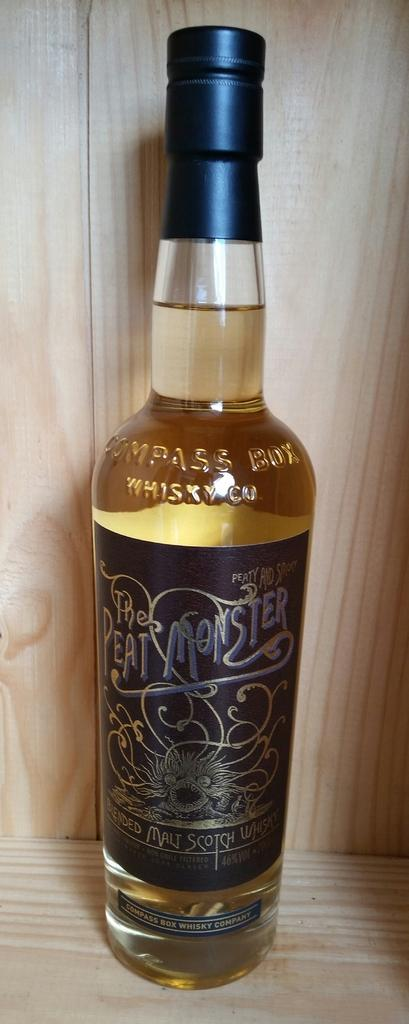<image>
Render a clear and concise summary of the photo. Beer bottle for Peat Monster on top of a wooden surface. 